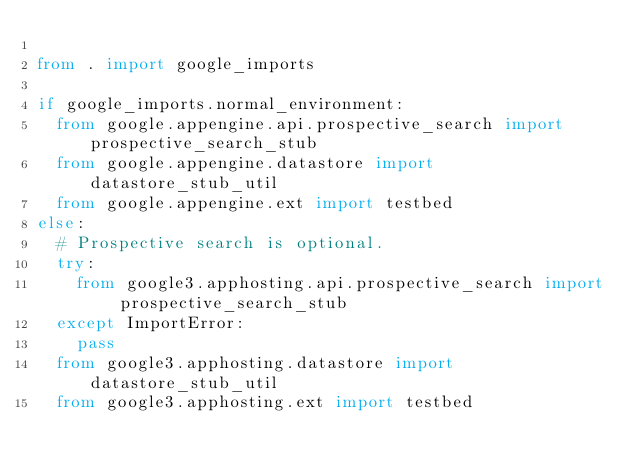Convert code to text. <code><loc_0><loc_0><loc_500><loc_500><_Python_>
from . import google_imports

if google_imports.normal_environment:
  from google.appengine.api.prospective_search import prospective_search_stub
  from google.appengine.datastore import datastore_stub_util
  from google.appengine.ext import testbed
else:
  # Prospective search is optional.
  try:
    from google3.apphosting.api.prospective_search import prospective_search_stub
  except ImportError:
    pass
  from google3.apphosting.datastore import datastore_stub_util
  from google3.apphosting.ext import testbed
</code> 